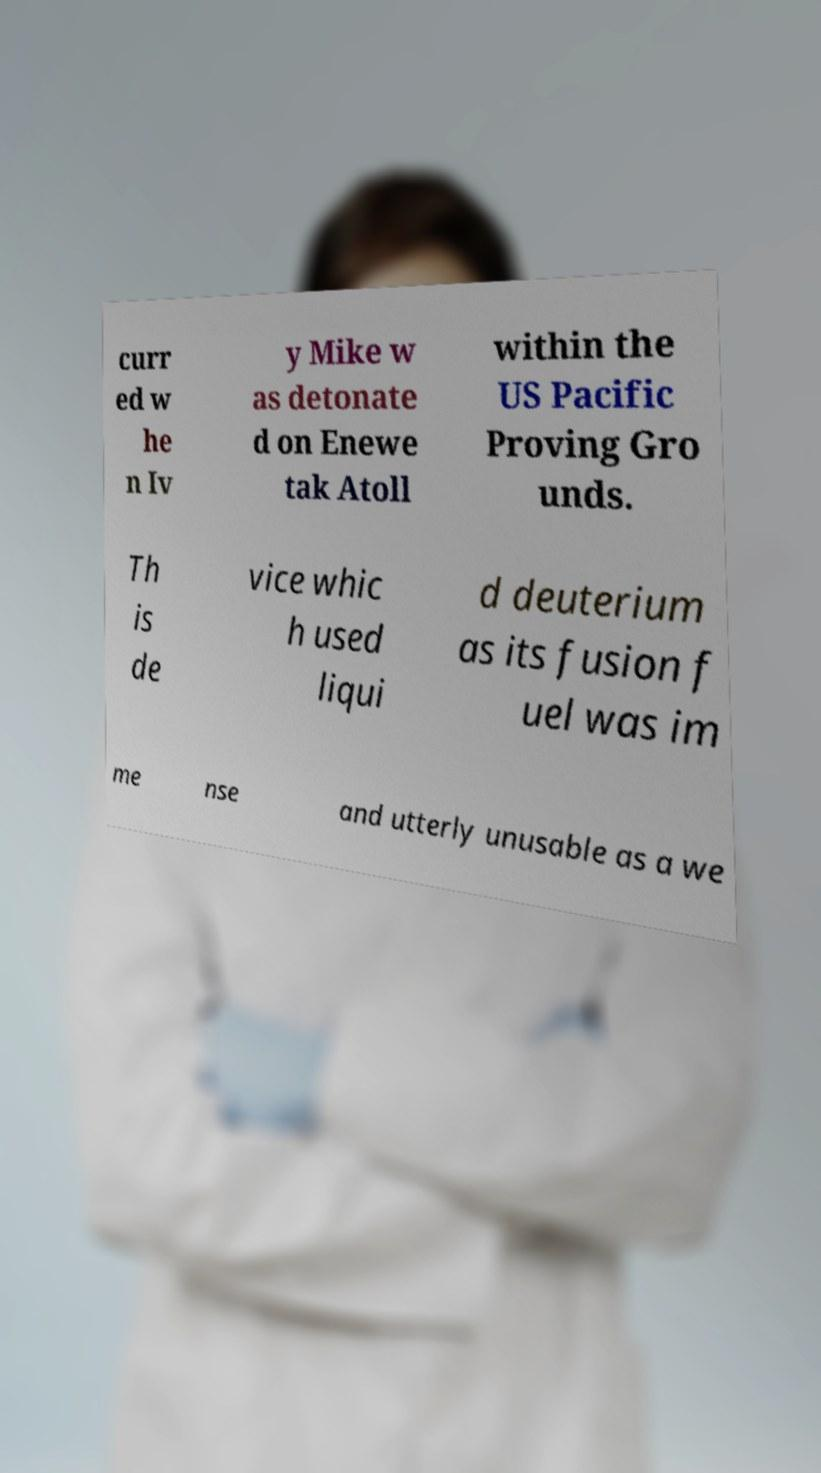What messages or text are displayed in this image? I need them in a readable, typed format. curr ed w he n Iv y Mike w as detonate d on Enewe tak Atoll within the US Pacific Proving Gro unds. Th is de vice whic h used liqui d deuterium as its fusion f uel was im me nse and utterly unusable as a we 